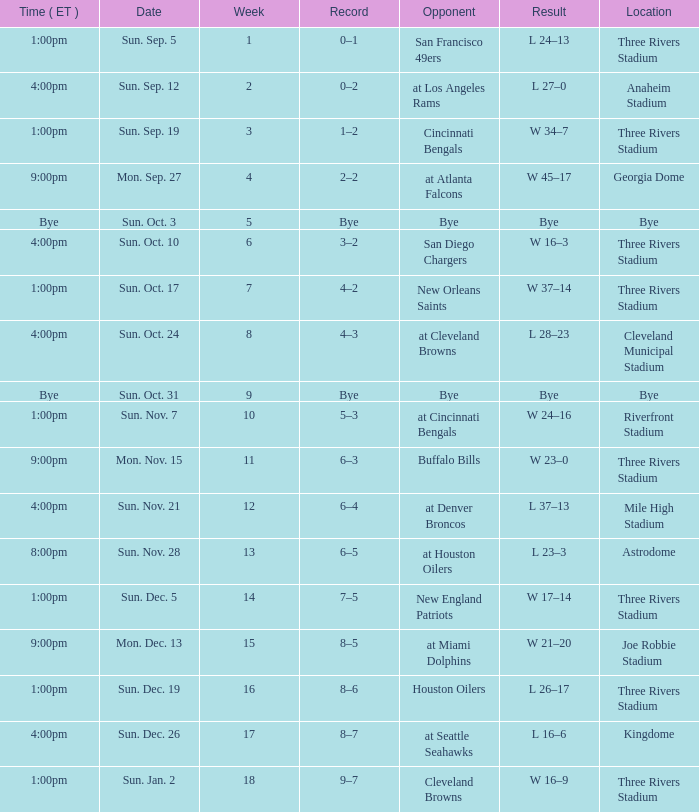What is the average Week for the game at three rivers stadium, with a Record of 3–2? 6.0. 